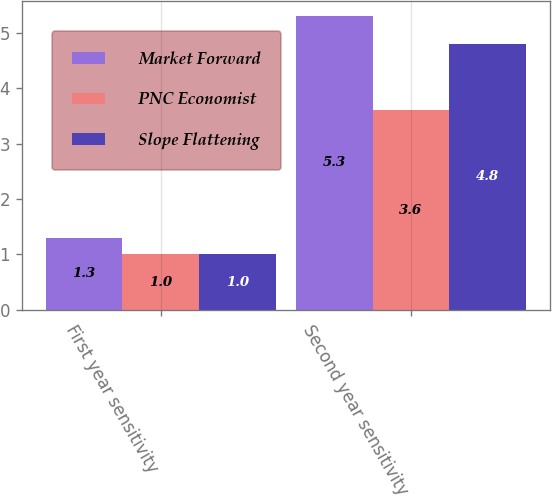<chart> <loc_0><loc_0><loc_500><loc_500><stacked_bar_chart><ecel><fcel>First year sensitivity<fcel>Second year sensitivity<nl><fcel>Market Forward<fcel>1.3<fcel>5.3<nl><fcel>PNC Economist<fcel>1<fcel>3.6<nl><fcel>Slope Flattening<fcel>1<fcel>4.8<nl></chart> 